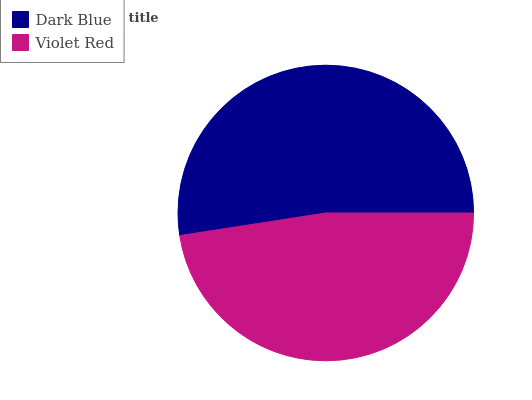Is Violet Red the minimum?
Answer yes or no. Yes. Is Dark Blue the maximum?
Answer yes or no. Yes. Is Violet Red the maximum?
Answer yes or no. No. Is Dark Blue greater than Violet Red?
Answer yes or no. Yes. Is Violet Red less than Dark Blue?
Answer yes or no. Yes. Is Violet Red greater than Dark Blue?
Answer yes or no. No. Is Dark Blue less than Violet Red?
Answer yes or no. No. Is Dark Blue the high median?
Answer yes or no. Yes. Is Violet Red the low median?
Answer yes or no. Yes. Is Violet Red the high median?
Answer yes or no. No. Is Dark Blue the low median?
Answer yes or no. No. 